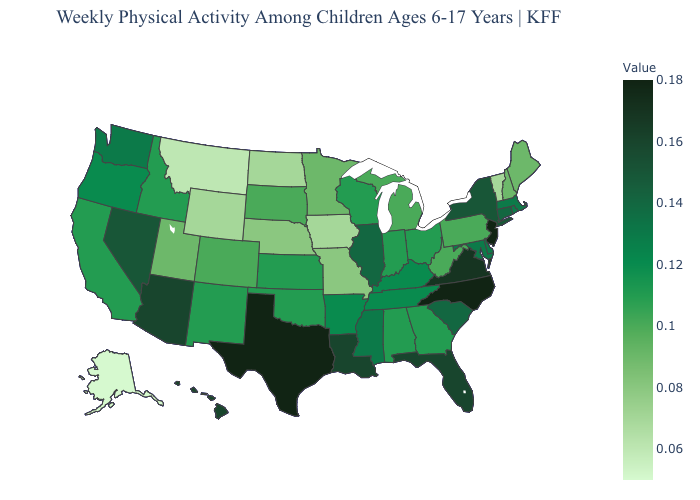Among the states that border Illinois , which have the highest value?
Quick response, please. Kentucky. Does Nebraska have a higher value than Alaska?
Answer briefly. Yes. Does the map have missing data?
Quick response, please. No. Which states hav the highest value in the Northeast?
Keep it brief. New Jersey. Does West Virginia have the lowest value in the South?
Keep it brief. Yes. 